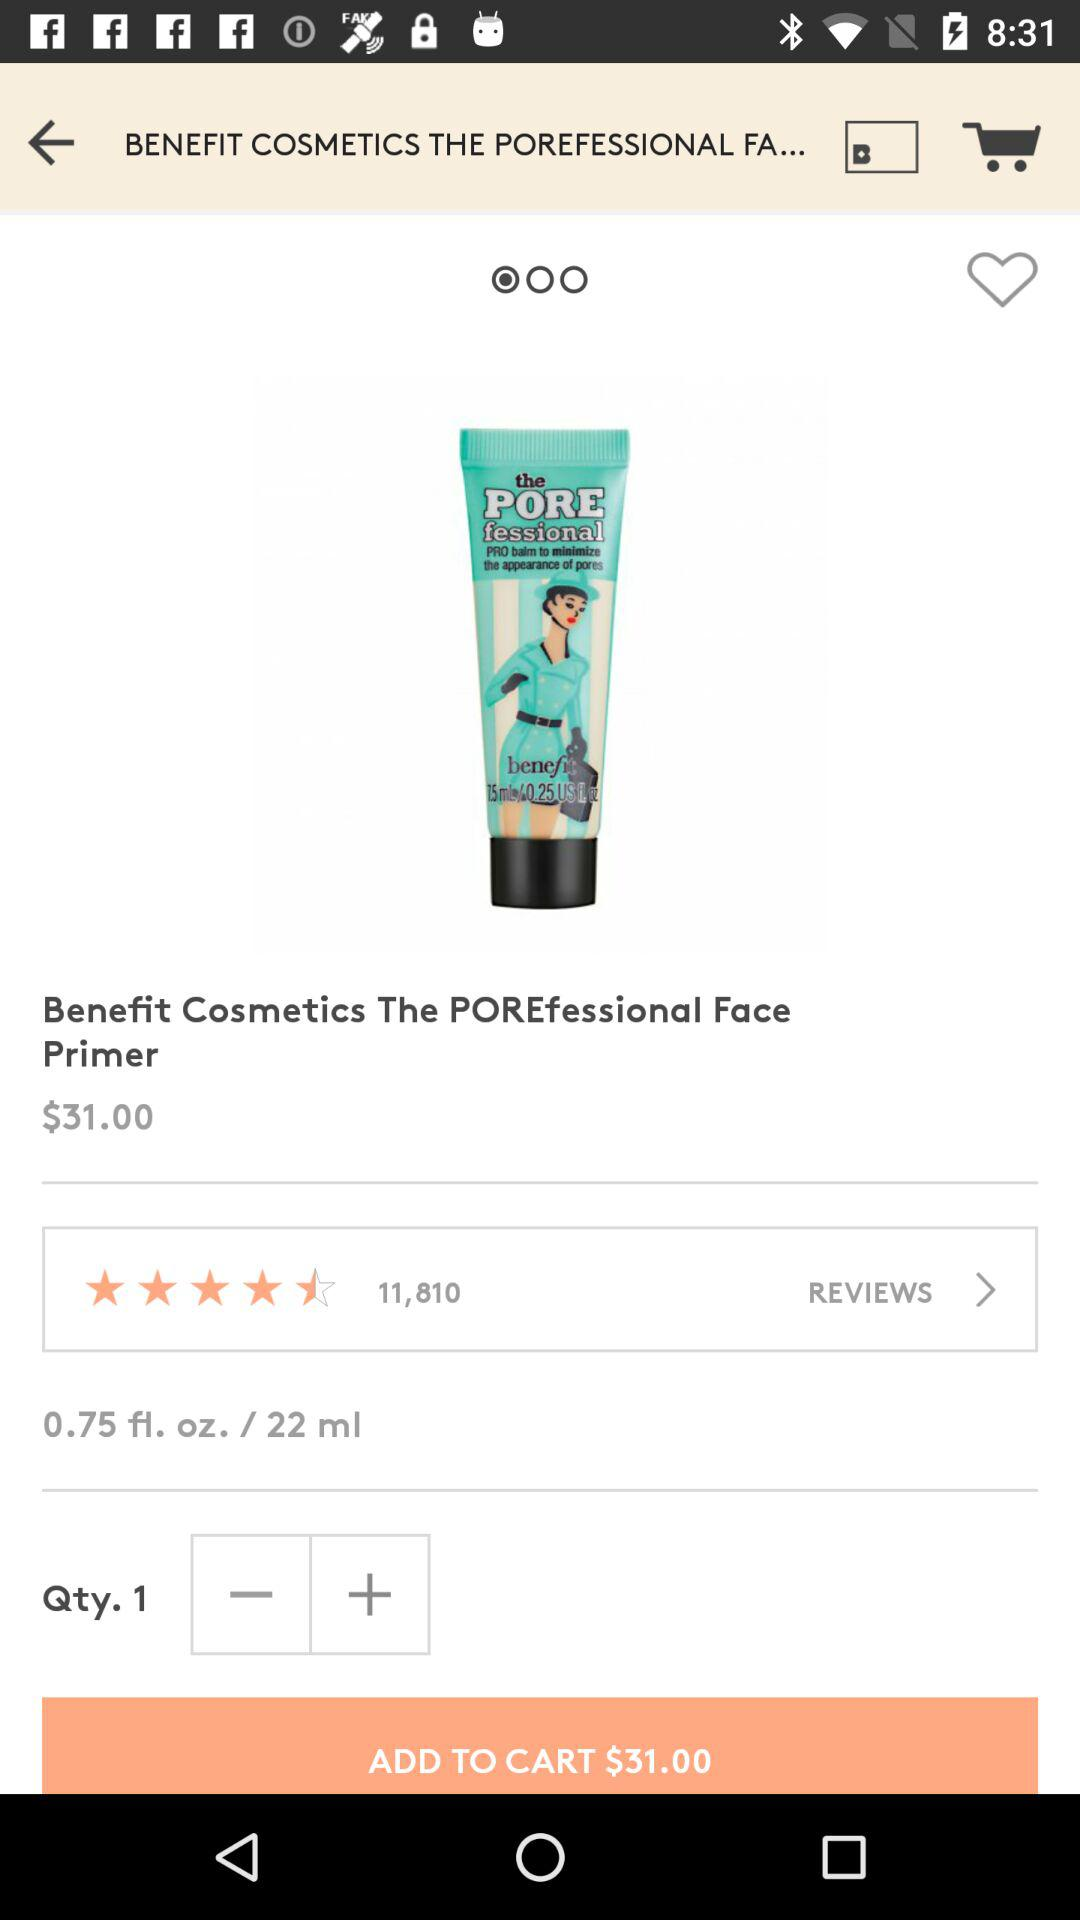What is the cost of the product? The cost of the product is $31.00. 